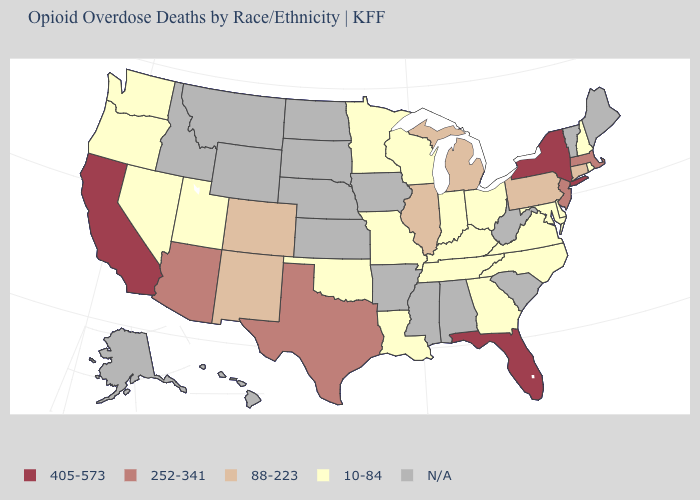What is the highest value in states that border Washington?
Keep it brief. 10-84. Name the states that have a value in the range N/A?
Keep it brief. Alabama, Alaska, Arkansas, Hawaii, Idaho, Iowa, Kansas, Maine, Mississippi, Montana, Nebraska, North Dakota, South Carolina, South Dakota, Vermont, West Virginia, Wyoming. Among the states that border South Carolina , which have the highest value?
Write a very short answer. Georgia, North Carolina. What is the value of New York?
Concise answer only. 405-573. Which states hav the highest value in the Northeast?
Write a very short answer. New York. What is the value of Wisconsin?
Concise answer only. 10-84. Does Connecticut have the highest value in the USA?
Write a very short answer. No. Name the states that have a value in the range 10-84?
Keep it brief. Delaware, Georgia, Indiana, Kentucky, Louisiana, Maryland, Minnesota, Missouri, Nevada, New Hampshire, North Carolina, Ohio, Oklahoma, Oregon, Rhode Island, Tennessee, Utah, Virginia, Washington, Wisconsin. What is the lowest value in the Northeast?
Give a very brief answer. 10-84. What is the value of Tennessee?
Quick response, please. 10-84. Name the states that have a value in the range 252-341?
Write a very short answer. Arizona, Massachusetts, New Jersey, Texas. What is the highest value in the USA?
Short answer required. 405-573. What is the lowest value in states that border Texas?
Quick response, please. 10-84. What is the value of Louisiana?
Quick response, please. 10-84. 